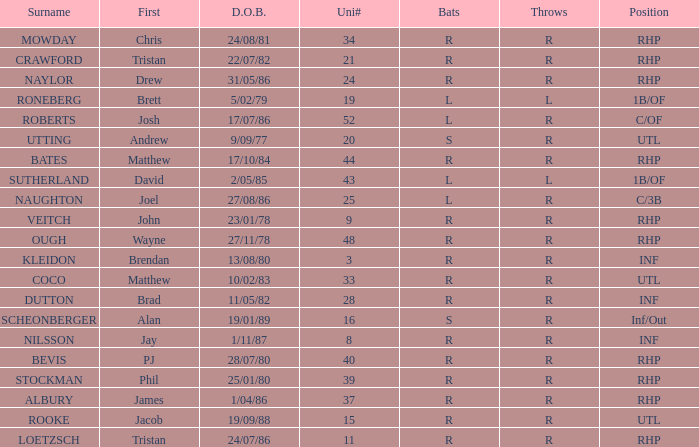Parse the full table. {'header': ['Surname', 'First', 'D.O.B.', 'Uni#', 'Bats', 'Throws', 'Position'], 'rows': [['MOWDAY', 'Chris', '24/08/81', '34', 'R', 'R', 'RHP'], ['CRAWFORD', 'Tristan', '22/07/82', '21', 'R', 'R', 'RHP'], ['NAYLOR', 'Drew', '31/05/86', '24', 'R', 'R', 'RHP'], ['RONEBERG', 'Brett', '5/02/79', '19', 'L', 'L', '1B/OF'], ['ROBERTS', 'Josh', '17/07/86', '52', 'L', 'R', 'C/OF'], ['UTTING', 'Andrew', '9/09/77', '20', 'S', 'R', 'UTL'], ['BATES', 'Matthew', '17/10/84', '44', 'R', 'R', 'RHP'], ['SUTHERLAND', 'David', '2/05/85', '43', 'L', 'L', '1B/OF'], ['NAUGHTON', 'Joel', '27/08/86', '25', 'L', 'R', 'C/3B'], ['VEITCH', 'John', '23/01/78', '9', 'R', 'R', 'RHP'], ['OUGH', 'Wayne', '27/11/78', '48', 'R', 'R', 'RHP'], ['KLEIDON', 'Brendan', '13/08/80', '3', 'R', 'R', 'INF'], ['COCO', 'Matthew', '10/02/83', '33', 'R', 'R', 'UTL'], ['DUTTON', 'Brad', '11/05/82', '28', 'R', 'R', 'INF'], ['SCHEONBERGER', 'Alan', '19/01/89', '16', 'S', 'R', 'Inf/Out'], ['NILSSON', 'Jay', '1/11/87', '8', 'R', 'R', 'INF'], ['BEVIS', 'PJ', '28/07/80', '40', 'R', 'R', 'RHP'], ['STOCKMAN', 'Phil', '25/01/80', '39', 'R', 'R', 'RHP'], ['ALBURY', 'James', '1/04/86', '37', 'R', 'R', 'RHP'], ['ROOKE', 'Jacob', '19/09/88', '15', 'R', 'R', 'UTL'], ['LOETZSCH', 'Tristan', '24/07/86', '11', 'R', 'R', 'RHP']]} Which Position has a Surname of naylor? RHP. 